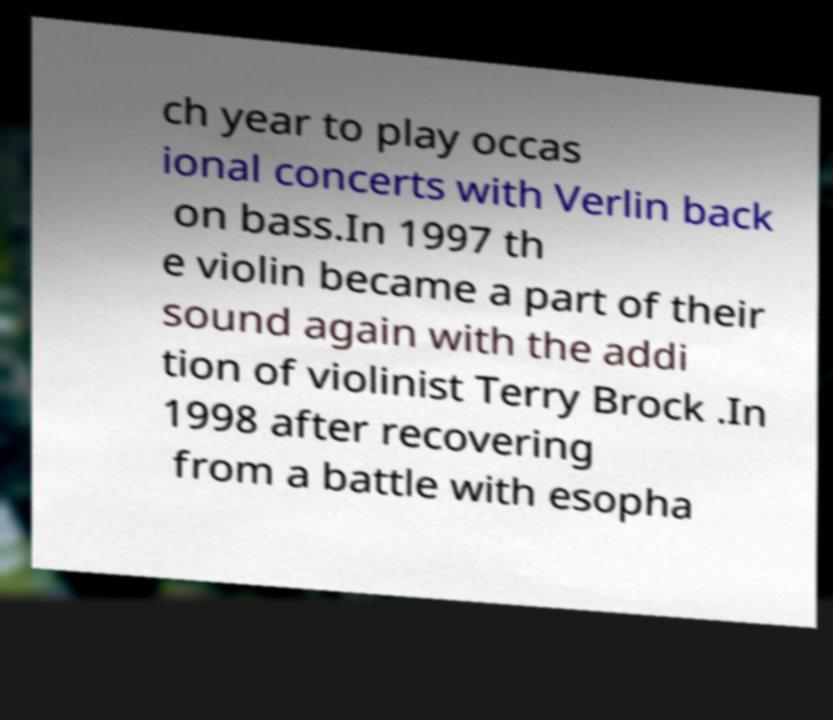For documentation purposes, I need the text within this image transcribed. Could you provide that? ch year to play occas ional concerts with Verlin back on bass.In 1997 th e violin became a part of their sound again with the addi tion of violinist Terry Brock .In 1998 after recovering from a battle with esopha 